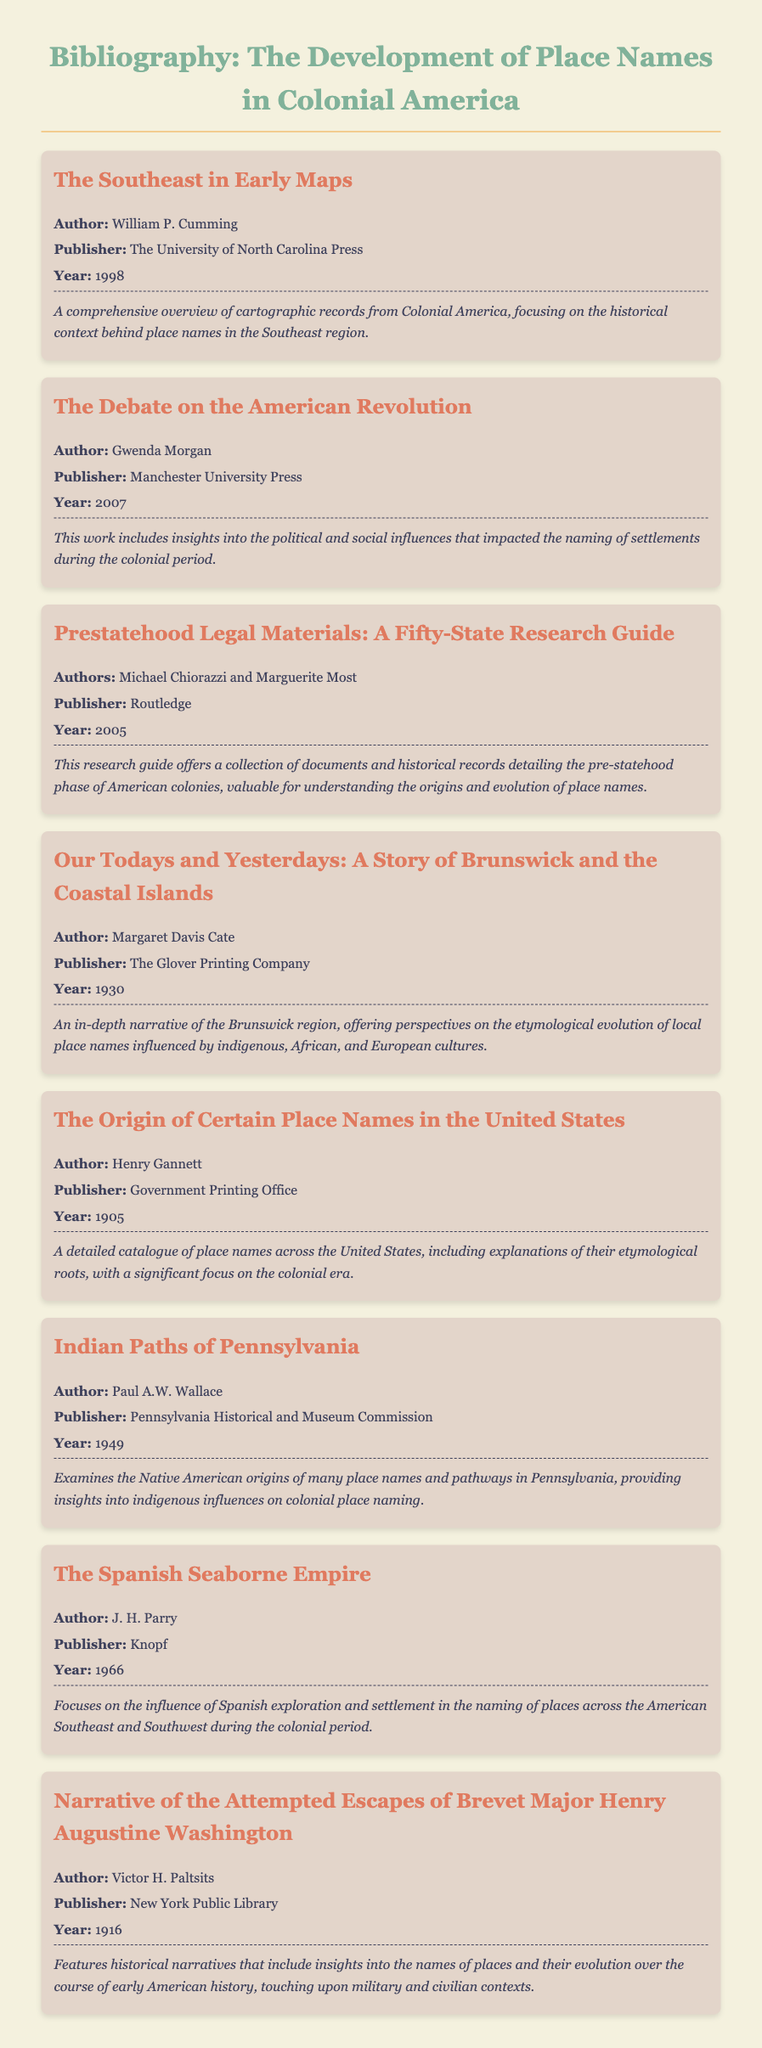What is the title of the first item? The title of the first item in the bibliography is "The Southeast in Early Maps."
Answer: The Southeast in Early Maps Who is the author of the book published in 2007? The author of the book published in 2007, "The Debate on the American Revolution," is Gwenda Morgan.
Answer: Gwenda Morgan Which publisher released "Our Todays and Yesterdays"? The publisher of "Our Todays and Yesterdays" is The Glover Printing Company.
Answer: The Glover Printing Company In what year was "The Origin of Certain Place Names in the United States" published? "The Origin of Certain Place Names in the United States" was published in 1905.
Answer: 1905 What subject does "Indian Paths of Pennsylvania" primarily examine? "Indian Paths of Pennsylvania" examines Native American origins of place names and pathways in Pennsylvania.
Answer: Native American origins How many bibliographic items focus on etymology? Two bibliographic items, "Our Todays and Yesterdays" and "The Origin of Certain Place Names in the United States," focus on etymology.
Answer: Two What common theme is present in the descriptions of multiple items? Multiple items address the influence of indigenous or European cultures on the naming of places.
Answer: Influence of indigenous or European cultures What type of document is presented here? The document is a bibliography providing references related to place names in Colonial America.
Answer: Bibliography 